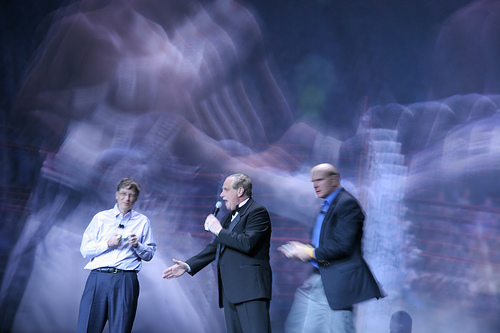<image>
Is there a microphone behind the man? No. The microphone is not behind the man. From this viewpoint, the microphone appears to be positioned elsewhere in the scene. 